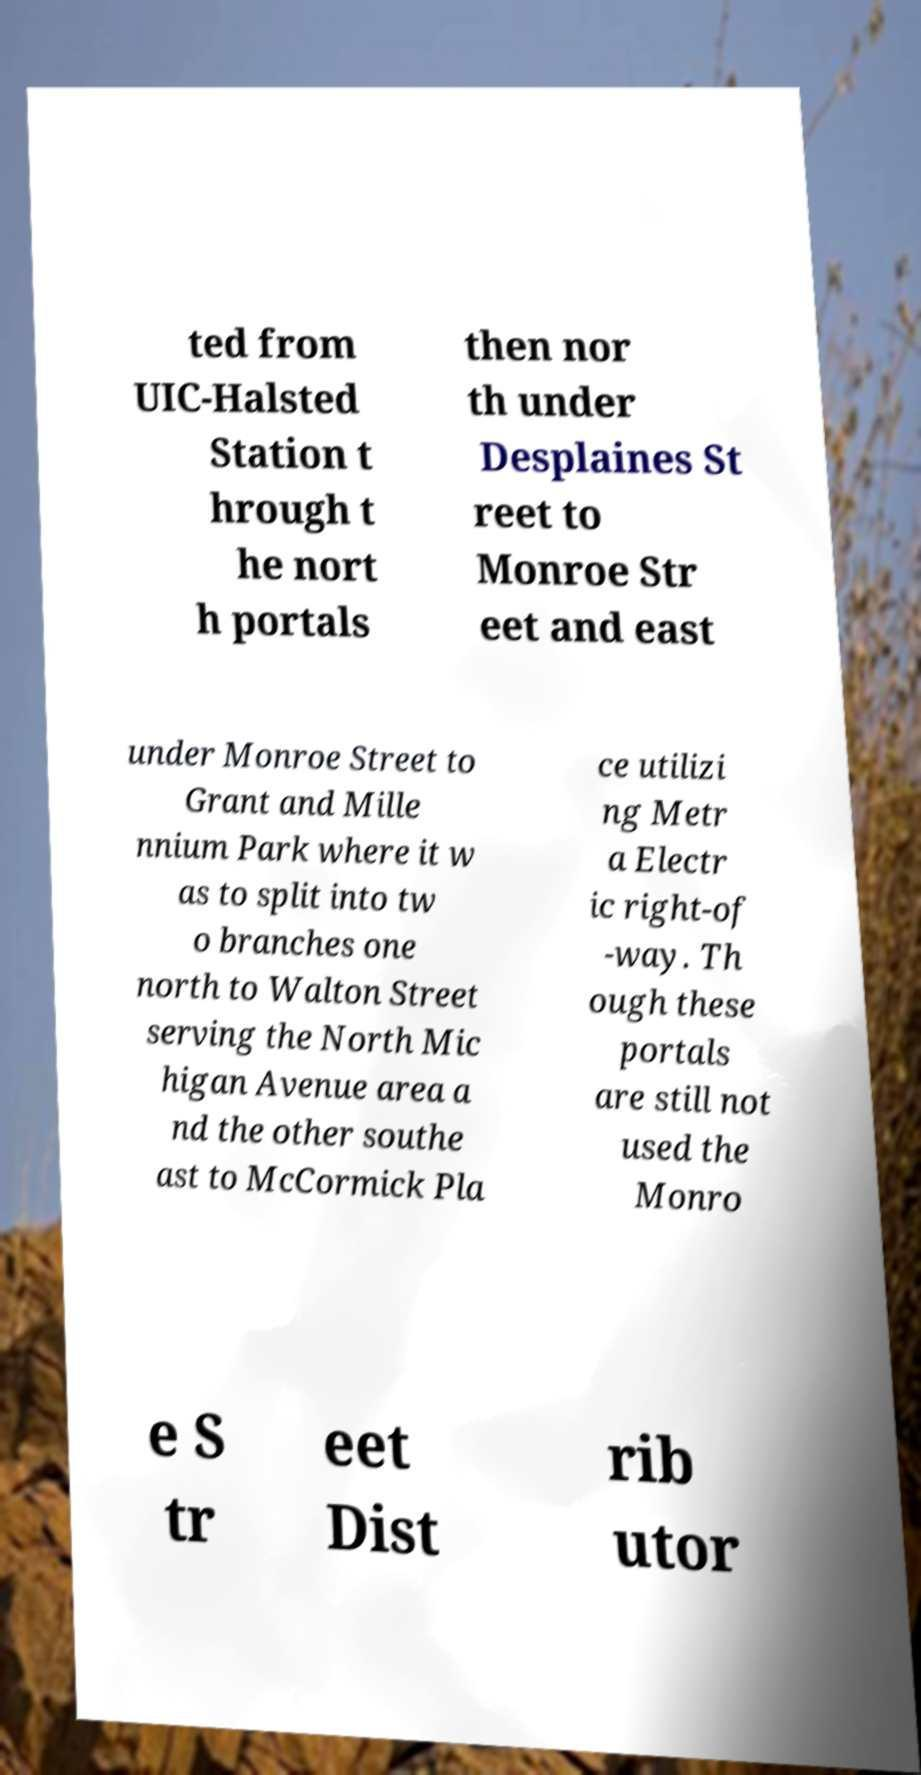There's text embedded in this image that I need extracted. Can you transcribe it verbatim? ted from UIC-Halsted Station t hrough t he nort h portals then nor th under Desplaines St reet to Monroe Str eet and east under Monroe Street to Grant and Mille nnium Park where it w as to split into tw o branches one north to Walton Street serving the North Mic higan Avenue area a nd the other southe ast to McCormick Pla ce utilizi ng Metr a Electr ic right-of -way. Th ough these portals are still not used the Monro e S tr eet Dist rib utor 